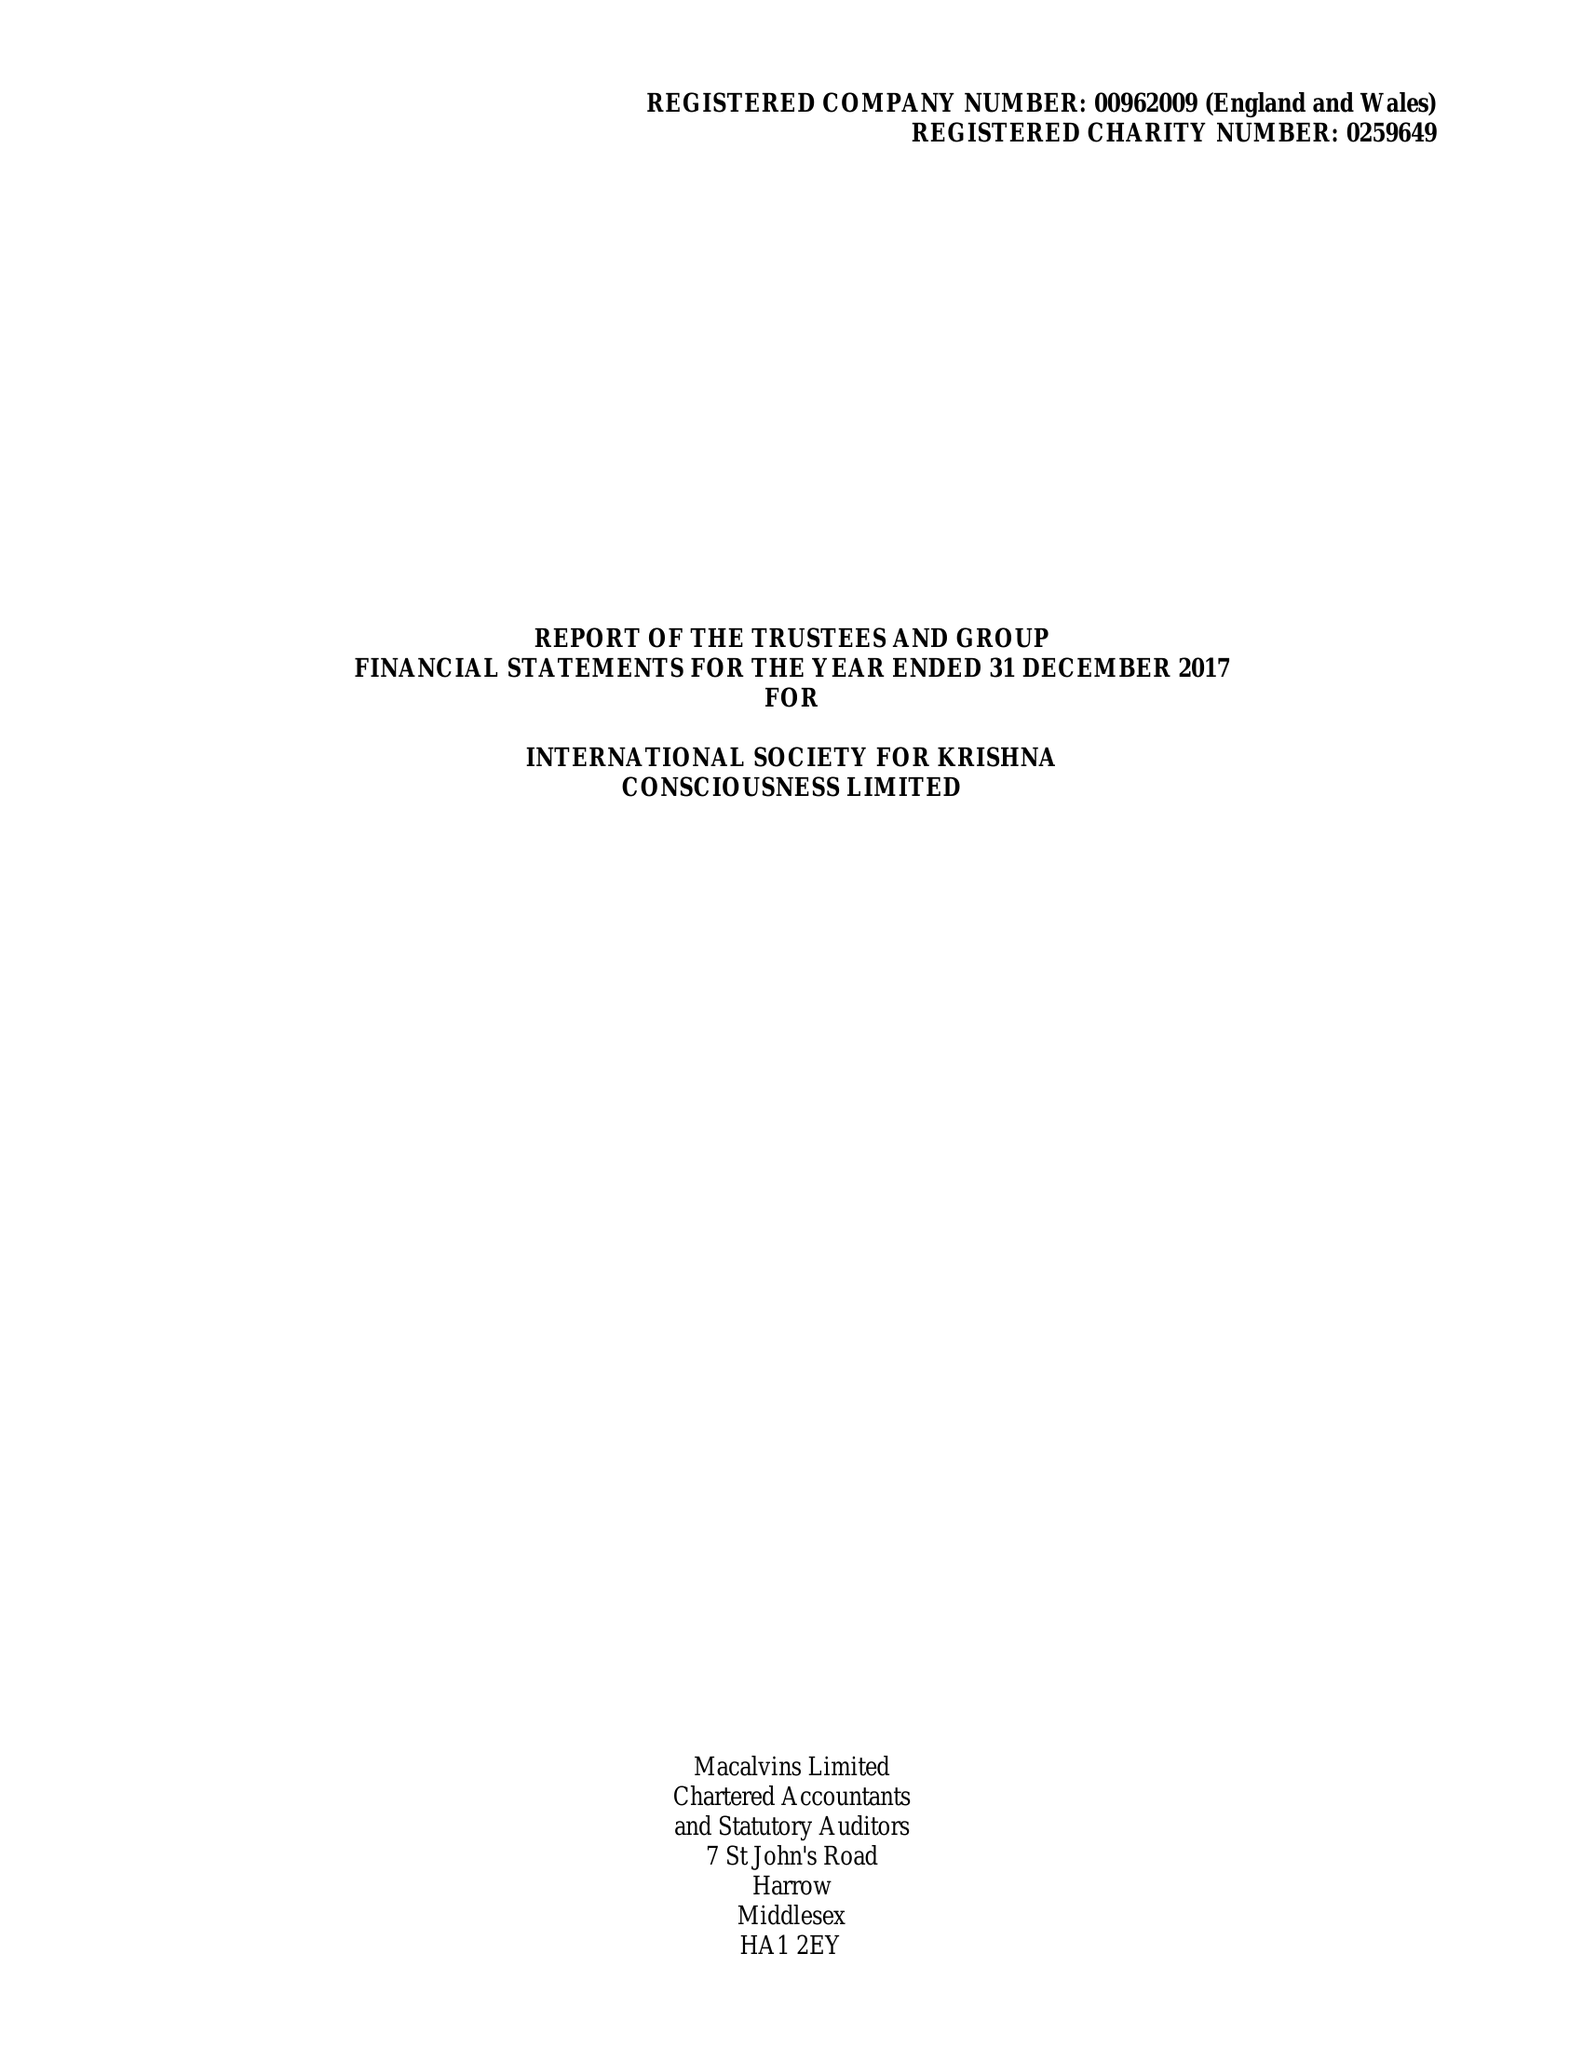What is the value for the report_date?
Answer the question using a single word or phrase. 2017-12-31 